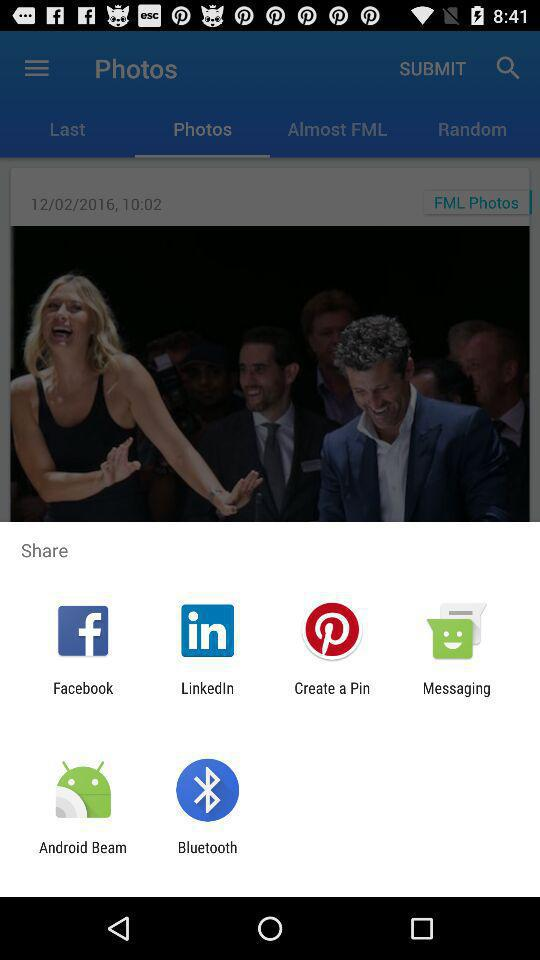What are the sharing options? The sharing options are "Facebook", "LinkedIn", "Create a Pin", "Messaging", "Android Beam" and "Bluetooth". 